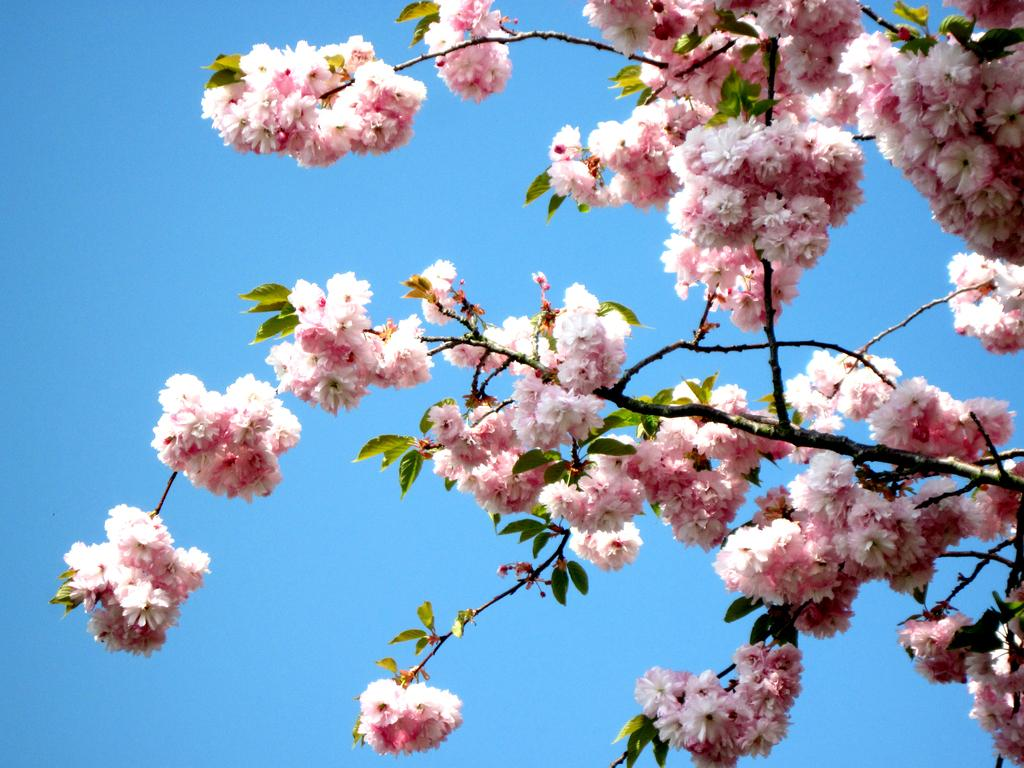What type of plants can be seen in the image? There are flowers and leaves in the image. What color is the sky in the image? The sky is blue in the image. What items are on the list in the image? A: There is no list present in the image. What type of scene is depicted in the image? The image depicts a scene with flowers, leaves, and a blue sky, but it does not fit into a specific scene category. 